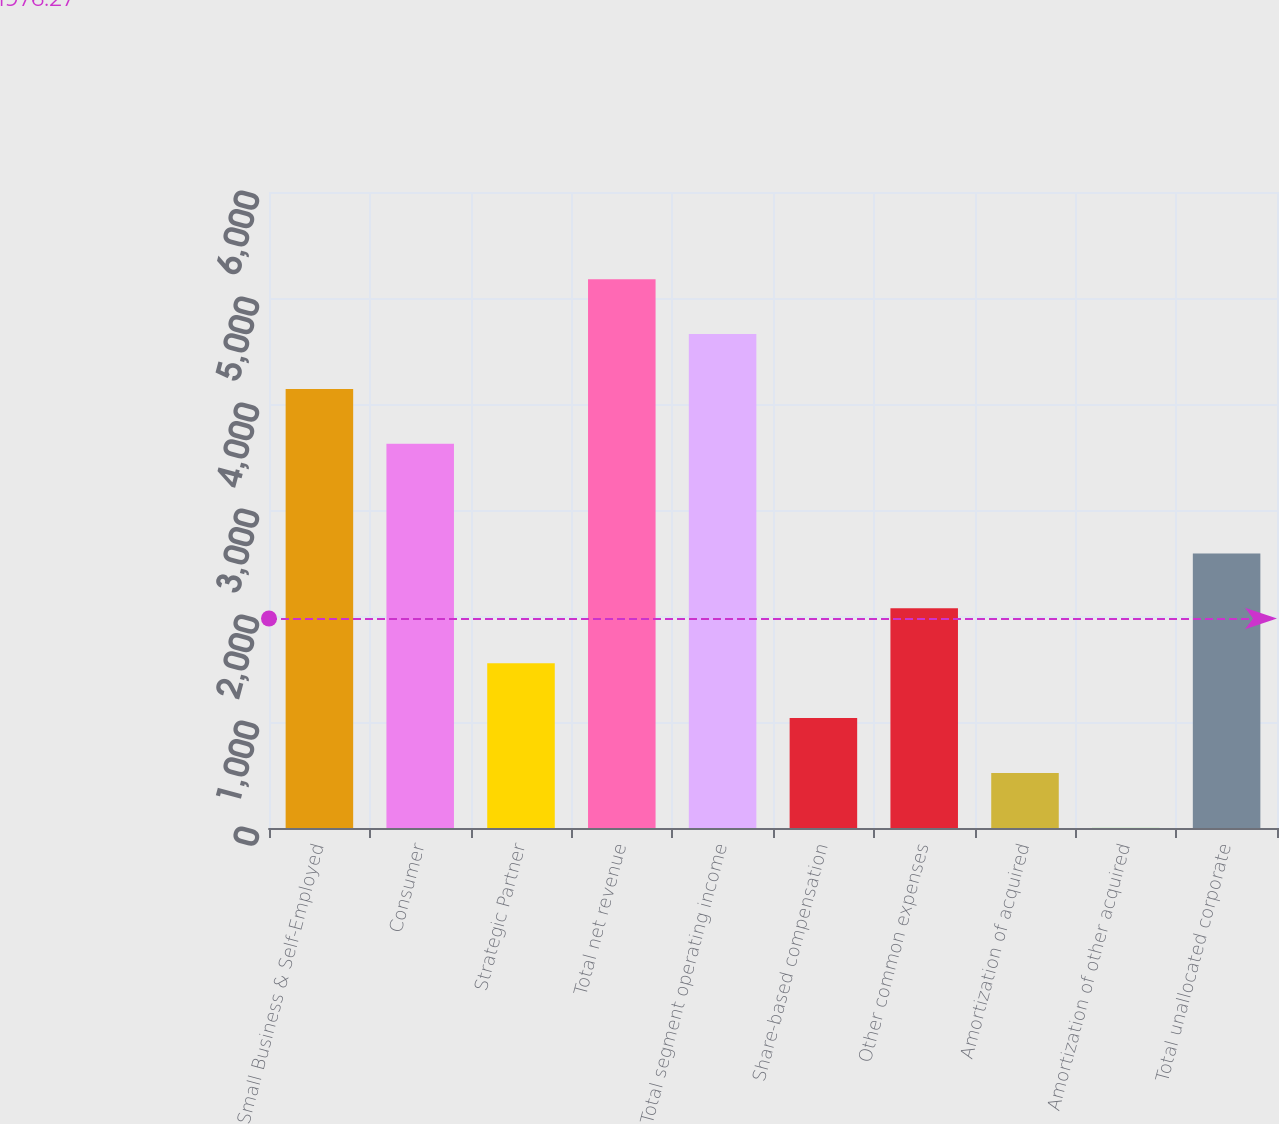<chart> <loc_0><loc_0><loc_500><loc_500><bar_chart><fcel>Small Business & Self-Employed<fcel>Consumer<fcel>Strategic Partner<fcel>Total net revenue<fcel>Total segment operating income<fcel>Share-based compensation<fcel>Other common expenses<fcel>Amortization of acquired<fcel>Amortization of other acquired<fcel>Total unallocated corporate<nl><fcel>4142<fcel>3624.5<fcel>1554.5<fcel>5177<fcel>4659.5<fcel>1037<fcel>2072<fcel>519.5<fcel>2<fcel>2589.5<nl></chart> 